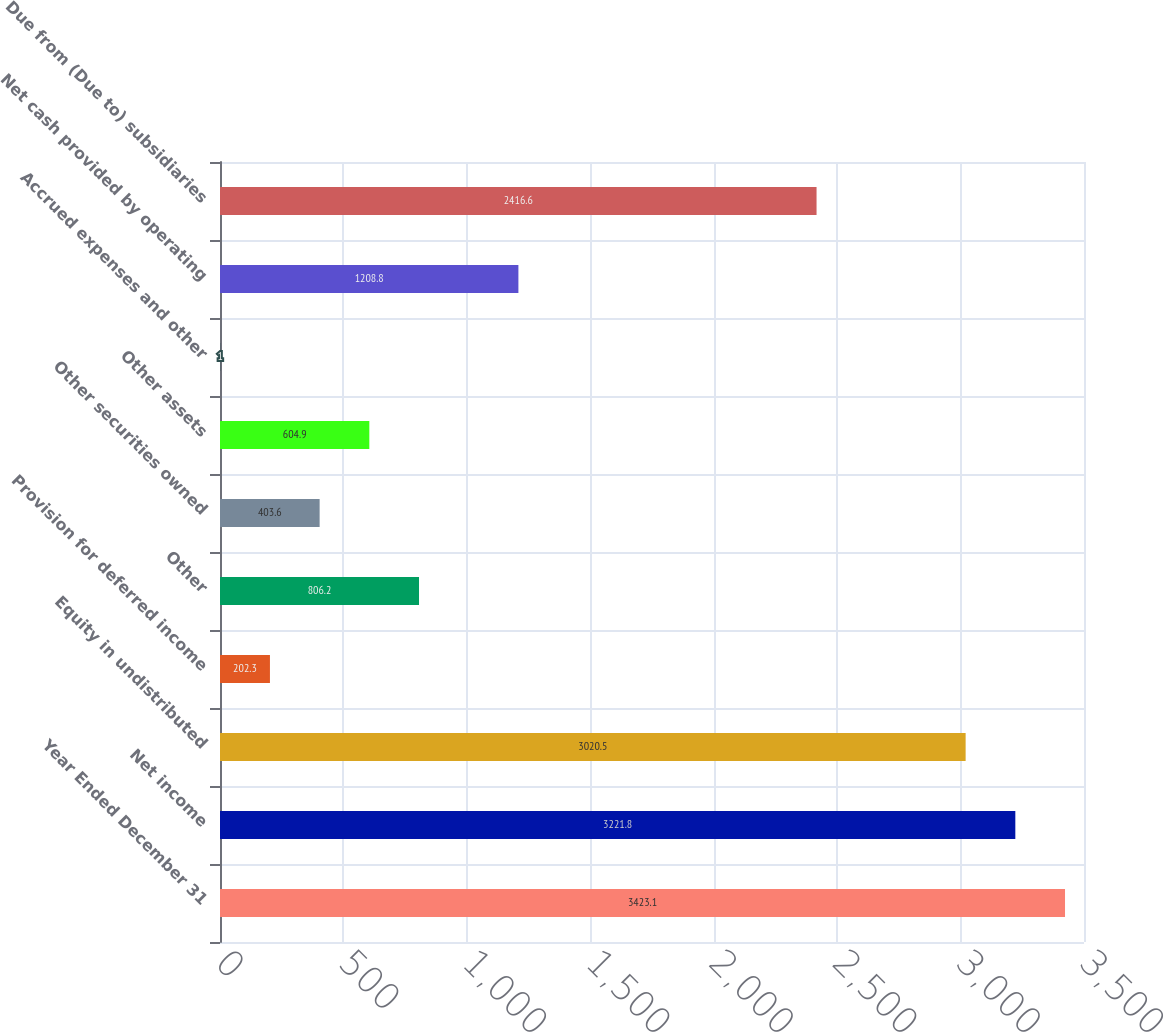Convert chart to OTSL. <chart><loc_0><loc_0><loc_500><loc_500><bar_chart><fcel>Year Ended December 31<fcel>Net income<fcel>Equity in undistributed<fcel>Provision for deferred income<fcel>Other<fcel>Other securities owned<fcel>Other assets<fcel>Accrued expenses and other<fcel>Net cash provided by operating<fcel>Due from (Due to) subsidiaries<nl><fcel>3423.1<fcel>3221.8<fcel>3020.5<fcel>202.3<fcel>806.2<fcel>403.6<fcel>604.9<fcel>1<fcel>1208.8<fcel>2416.6<nl></chart> 